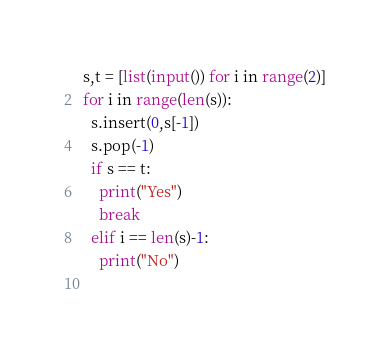Convert code to text. <code><loc_0><loc_0><loc_500><loc_500><_Python_>s,t = [list(input()) for i in range(2)]
for i in range(len(s)):
  s.insert(0,s[-1])
  s.pop(-1)
  if s == t:
    print("Yes")
    break
  elif i == len(s)-1:
    print("No")
  </code> 